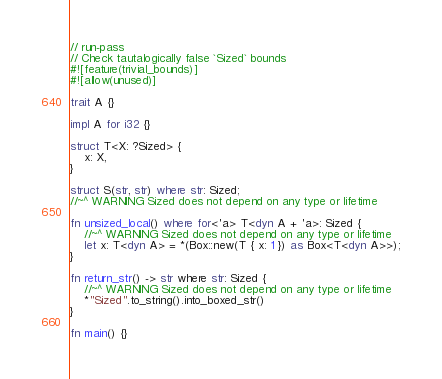<code> <loc_0><loc_0><loc_500><loc_500><_Rust_>// run-pass
// Check tautalogically false `Sized` bounds
#![feature(trivial_bounds)]
#![allow(unused)]

trait A {}

impl A for i32 {}

struct T<X: ?Sized> {
    x: X,
}

struct S(str, str) where str: Sized;
//~^ WARNING Sized does not depend on any type or lifetime

fn unsized_local() where for<'a> T<dyn A + 'a>: Sized {
    //~^ WARNING Sized does not depend on any type or lifetime
    let x: T<dyn A> = *(Box::new(T { x: 1 }) as Box<T<dyn A>>);
}

fn return_str() -> str where str: Sized {
    //~^ WARNING Sized does not depend on any type or lifetime
    *"Sized".to_string().into_boxed_str()
}

fn main() {}
</code> 